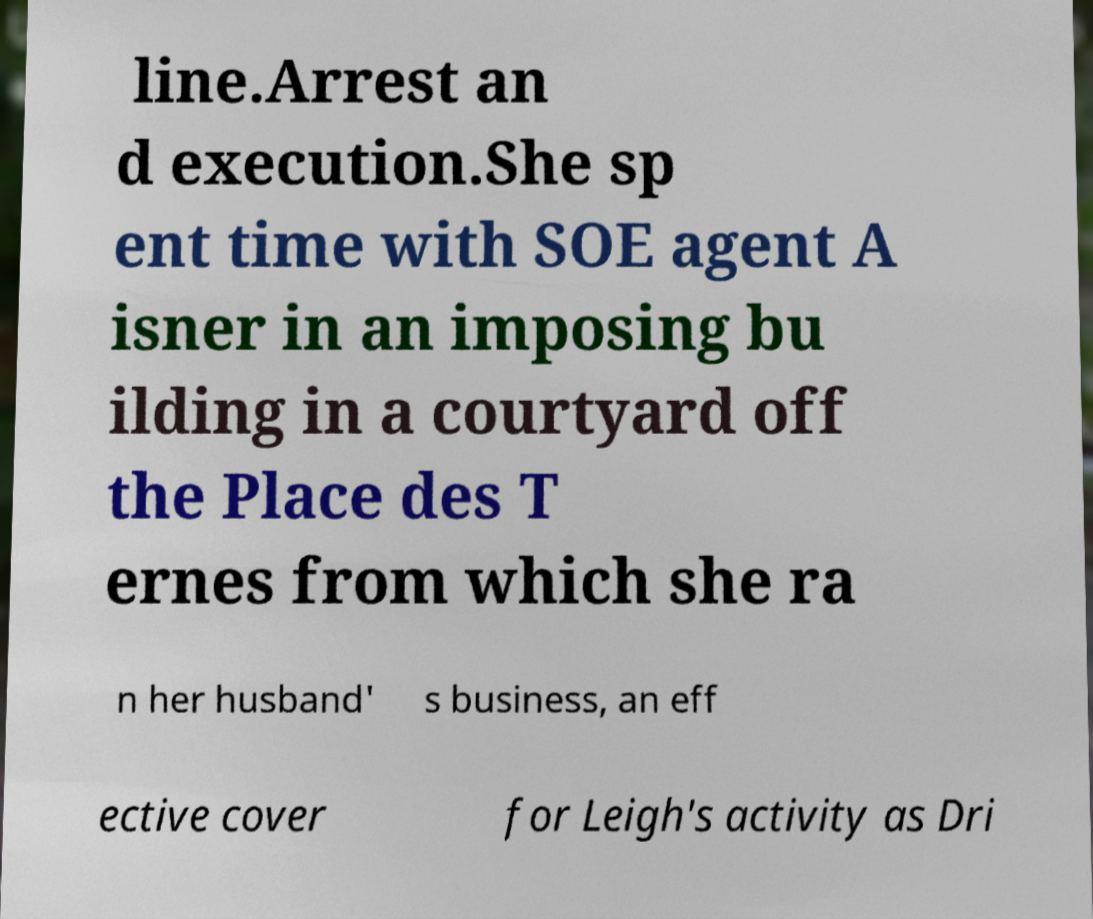Can you accurately transcribe the text from the provided image for me? line.Arrest an d execution.She sp ent time with SOE agent A isner in an imposing bu ilding in a courtyard off the Place des T ernes from which she ra n her husband' s business, an eff ective cover for Leigh's activity as Dri 